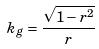<formula> <loc_0><loc_0><loc_500><loc_500>k _ { g } = \frac { \sqrt { 1 - r ^ { 2 } } } { r }</formula> 